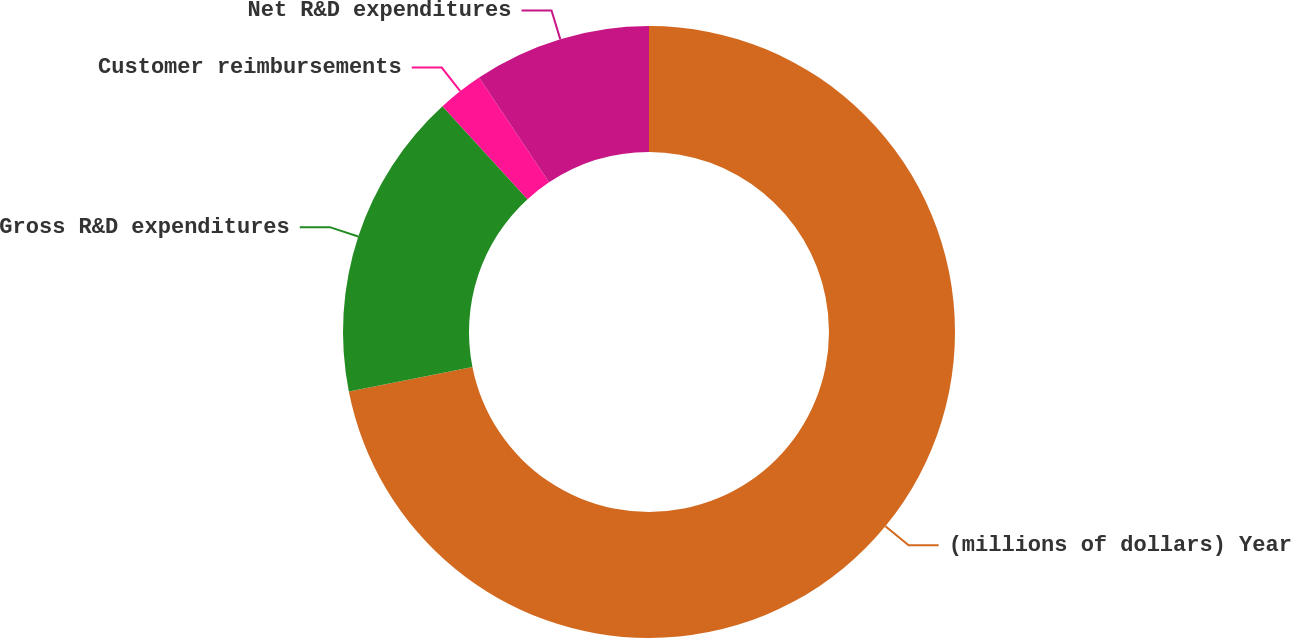<chart> <loc_0><loc_0><loc_500><loc_500><pie_chart><fcel>(millions of dollars) Year<fcel>Gross R&D expenditures<fcel>Customer reimbursements<fcel>Net R&D expenditures<nl><fcel>71.89%<fcel>16.32%<fcel>2.42%<fcel>9.37%<nl></chart> 